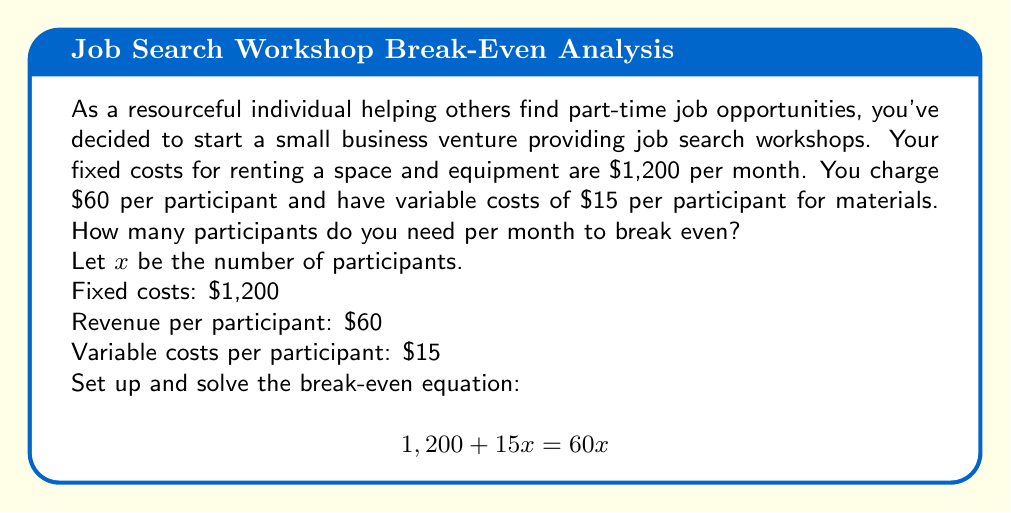Can you solve this math problem? To find the break-even point, we need to determine the number of participants where total revenue equals total costs.

1. Set up the equation:
   Total Costs = Total Revenue
   $1,200 + 15x = 60x$

2. Simplify the equation:
   $1,200 + 15x = 60x$
   $1,200 = 60x - 15x$
   $1,200 = 45x$

3. Solve for x:
   $x = 1,200 \div 45$
   $x = 26.67$

4. Since we can't have a fractional number of participants, we need to round up to the nearest whole number.

5. Therefore, you need 27 participants per month to break even.

To verify:
Total Revenue: $60 \times 27 = 1,620$
Total Costs: $1,200 + (15 \times 27) = 1,605$

At 27 participants, revenue slightly exceeds costs, confirming the break-even point.
Answer: The break-even point is 27 participants per month. 